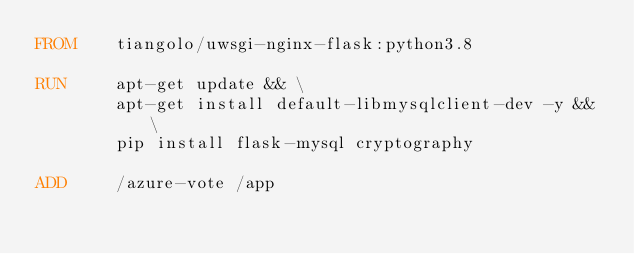Convert code to text. <code><loc_0><loc_0><loc_500><loc_500><_Dockerfile_>FROM    tiangolo/uwsgi-nginx-flask:python3.8

RUN     apt-get update && \
        apt-get install default-libmysqlclient-dev -y && \
        pip install flask-mysql cryptography
 
ADD     /azure-vote /app</code> 